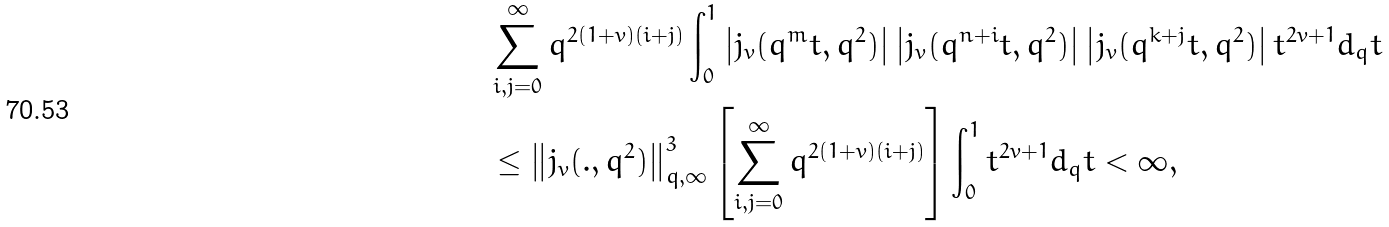<formula> <loc_0><loc_0><loc_500><loc_500>& \sum _ { i , j = 0 } ^ { \infty } q ^ { 2 ( 1 + v ) ( i + j ) } \int _ { 0 } ^ { 1 } \left | j _ { v } ( q ^ { m } t , q ^ { 2 } ) \right | \left | j _ { v } ( q ^ { n + i } t , q ^ { 2 } ) \right | \left | j _ { v } ( q ^ { k + j } t , q ^ { 2 } ) \right | t ^ { 2 v + 1 } d _ { q } t \\ & \leq \left \| j _ { v } ( . , q ^ { 2 } ) \right \| _ { q , \infty } ^ { 3 } \left [ \sum _ { i , j = 0 } ^ { \infty } q ^ { 2 ( 1 + v ) ( i + j ) } \right ] \int _ { 0 } ^ { 1 } t ^ { 2 v + 1 } d _ { q } t < \infty ,</formula> 